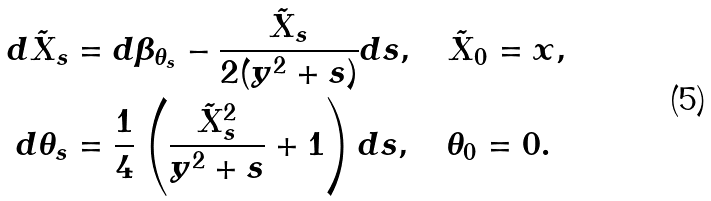<formula> <loc_0><loc_0><loc_500><loc_500>d \tilde { X } _ { s } & = d \beta _ { \theta _ { s } } - \frac { \tilde { X } _ { s } } { 2 ( y ^ { 2 } + s ) } d s , \quad \tilde { X } _ { 0 } = x , \\ d \theta _ { s } & = \frac { 1 } { 4 } \left ( \frac { \tilde { X } _ { s } ^ { 2 } } { y ^ { 2 } + s } + 1 \right ) d s , \quad \theta _ { 0 } = 0 .</formula> 